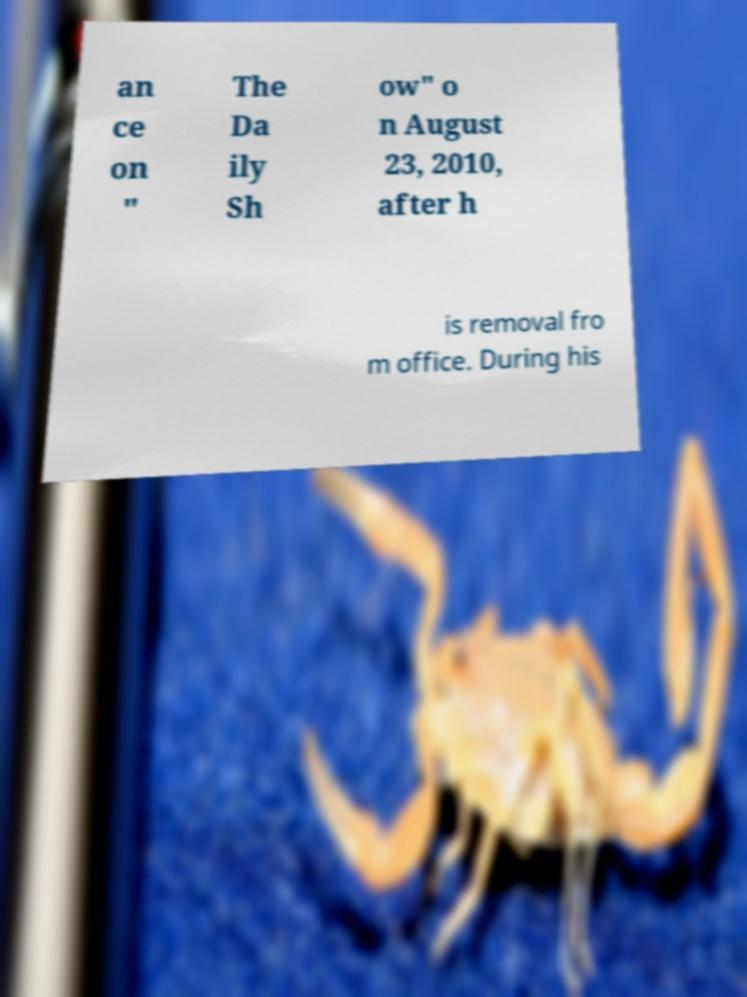Could you assist in decoding the text presented in this image and type it out clearly? an ce on " The Da ily Sh ow" o n August 23, 2010, after h is removal fro m office. During his 